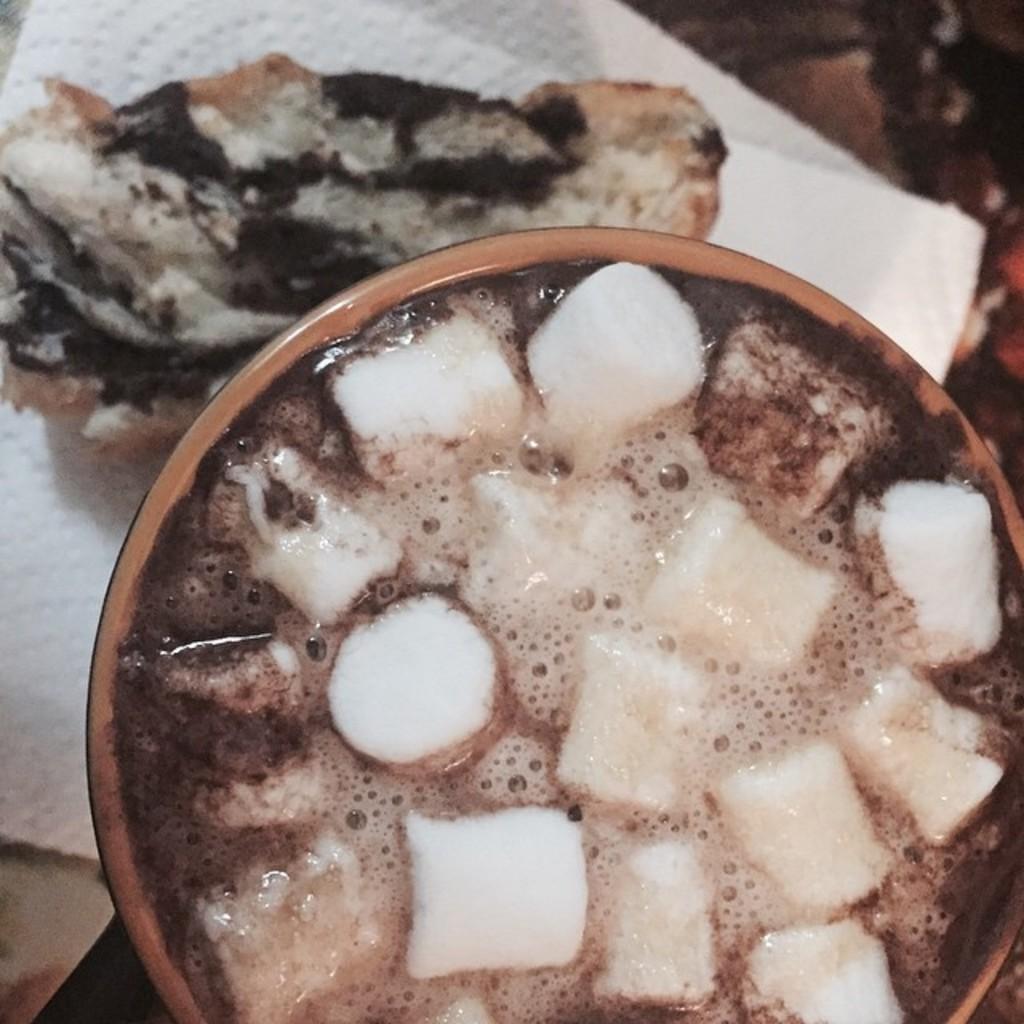Can you describe this image briefly? In this image I can see a bowl and I can see food item in the bowl and tissue paper inside the bowl 